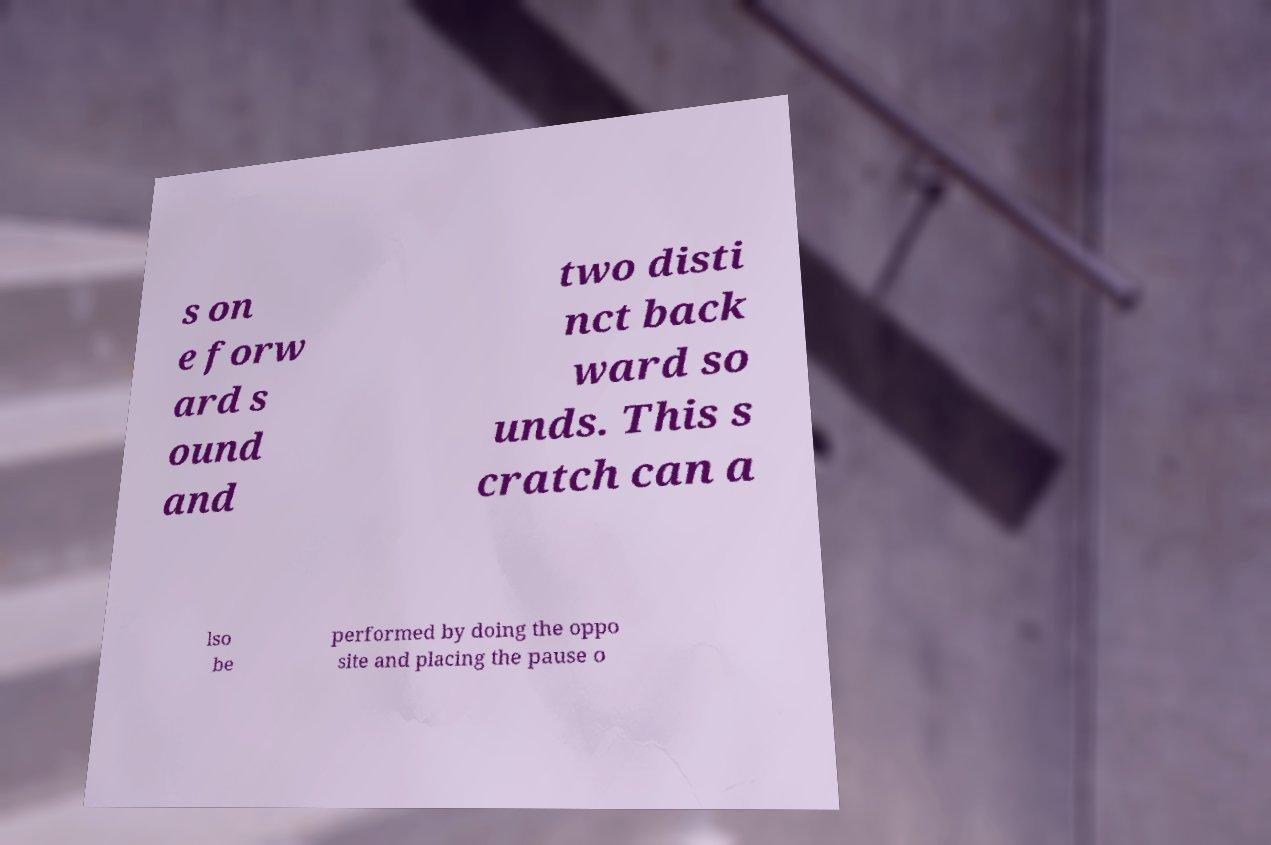Can you read and provide the text displayed in the image?This photo seems to have some interesting text. Can you extract and type it out for me? s on e forw ard s ound and two disti nct back ward so unds. This s cratch can a lso be performed by doing the oppo site and placing the pause o 